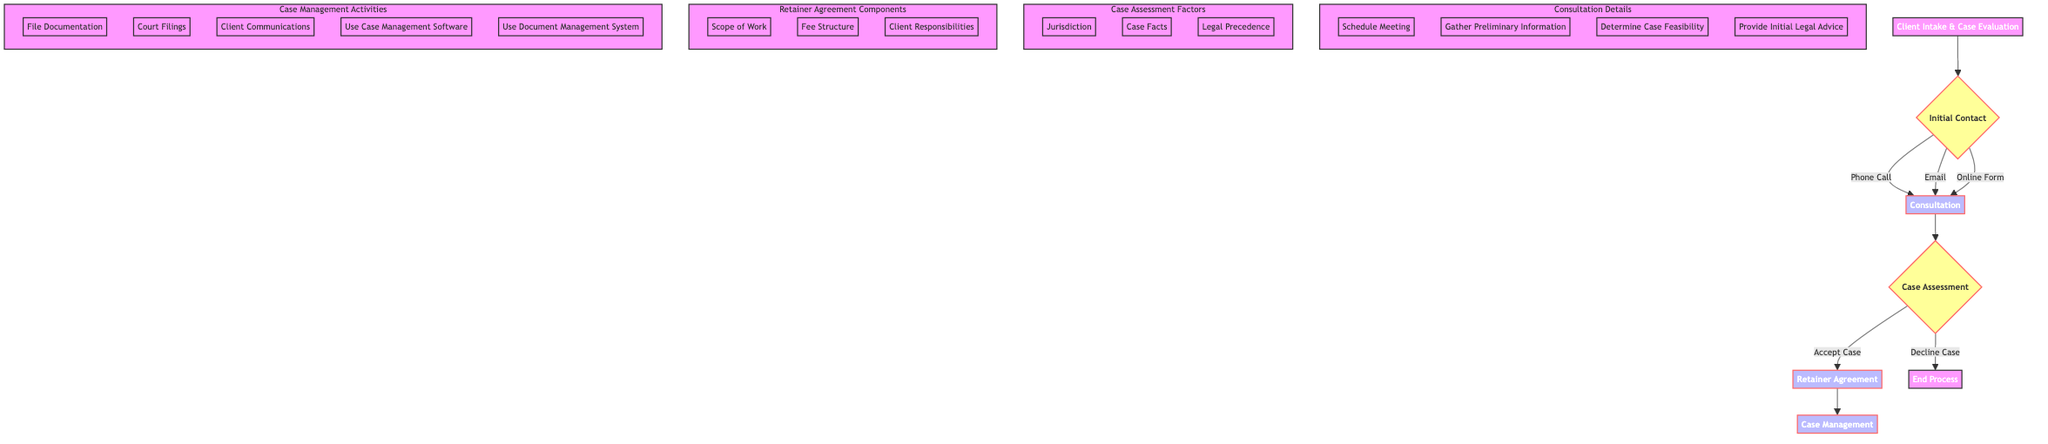What are the methods of initial contact? The diagram lists three methods under the node "Initial Contact": Phone Call, Email, and Online Form Submission. This information can be found directly connected to the "Initial Contact" node.
Answer: Phone Call, Email, Online Form Submission What are the outcomes of the consultation step? The "Consultation" node indicates two possible outcomes: "Case Feasibility Determined" and "Initial Legal Advice Provided." These outcomes are directly linked to the consultation process.
Answer: Case Feasibility Determined, Initial Legal Advice Provided How many factors are considered in case assessment? The diagram specifies three factors that are considered during "Case Assessment," which are "Jurisdiction," "Case Facts," and "Legal Precedence." These factors are grouped under the "Case Assessment Factors" subgraph.
Answer: 3 What happens if the case is declined during assessment? According to the "Case Assessment" decision node, if the case is declined, the flow of the diagram leads to the "End Process." This means that no further steps are taken if the decision is to decline the case.
Answer: End Process What are the components of the retainer agreement? The "Retainer Agreement" node outlines three components that define the agreement's details: "Scope of Work," "Fee Structure," and "Client Responsibilities." These are shown in the "Retainer Agreement Components" subgraph.
Answer: Scope of Work, Fee Structure, Client Responsibilities What activities are included in case management? The "Case Management" node details the ongoing activities involved, which include "File Documentation," "Court Filings," and "Client Communications," among others. These activities are listed in the "Case Management Activities" subgraph.
Answer: File Documentation, Court Filings, Client Communications What decision follows a successful case assessment? Upon assessing the case, if the outcome is to accept the case, the next step is to move to the "Retainer Agreement" node. This transition indicates that accepting the case allows for formalizing the agreement.
Answer: Retainer Agreement How is the initial consultation initiated? The initial consultation is initiated following any of the methods listed under "Initial Contact." This highlights that various communication methods can trigger the consultation process.
Answer: Consultation What tools are used in case management? The diagram lists two tools that are utilized in "Case Management," which are "Case Management Software" and "Document Management System." These tools are mentioned in the "Case Management Activities" subgraph.
Answer: Case Management Software, Document Management System 